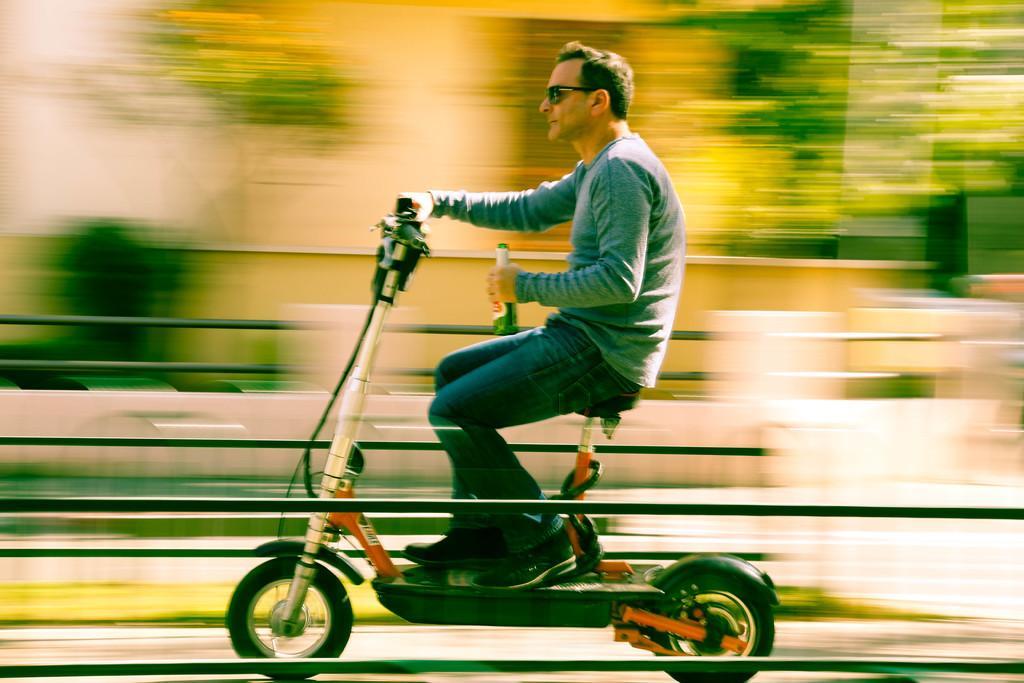Can you describe this image briefly? In this image I can see a man is riding a vehicle on the road and holding a glass bottle in his hands. 